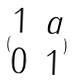Convert formula to latex. <formula><loc_0><loc_0><loc_500><loc_500>( \begin{matrix} 1 & a \\ 0 & 1 \end{matrix} )</formula> 